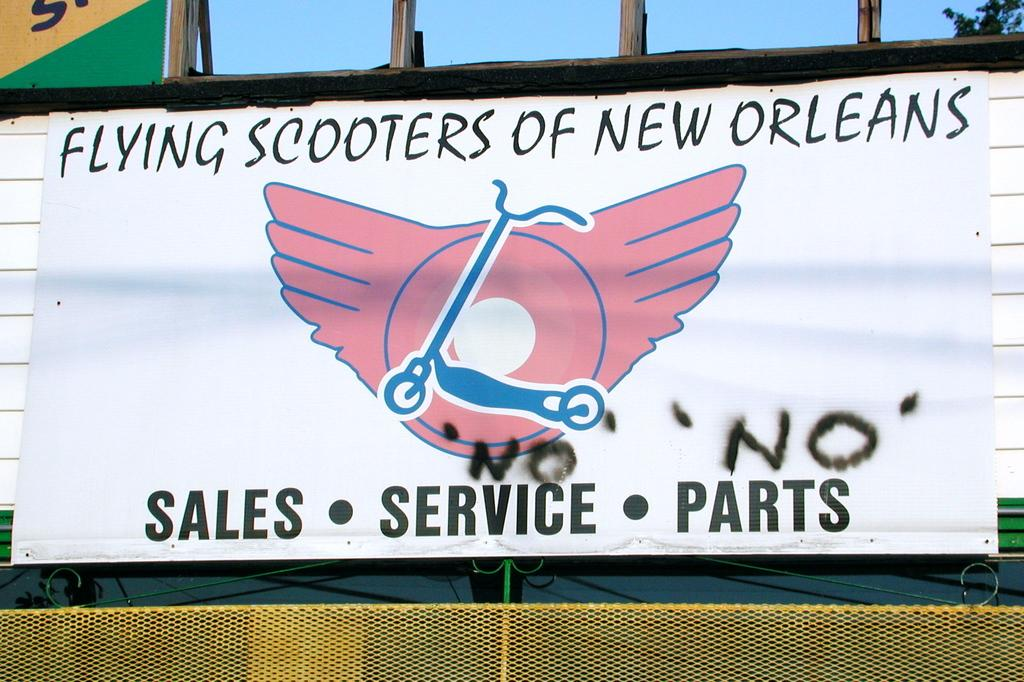<image>
Describe the image concisely. a poster for Flying Scooters of New Orleans with a logo of a scooter with wings 